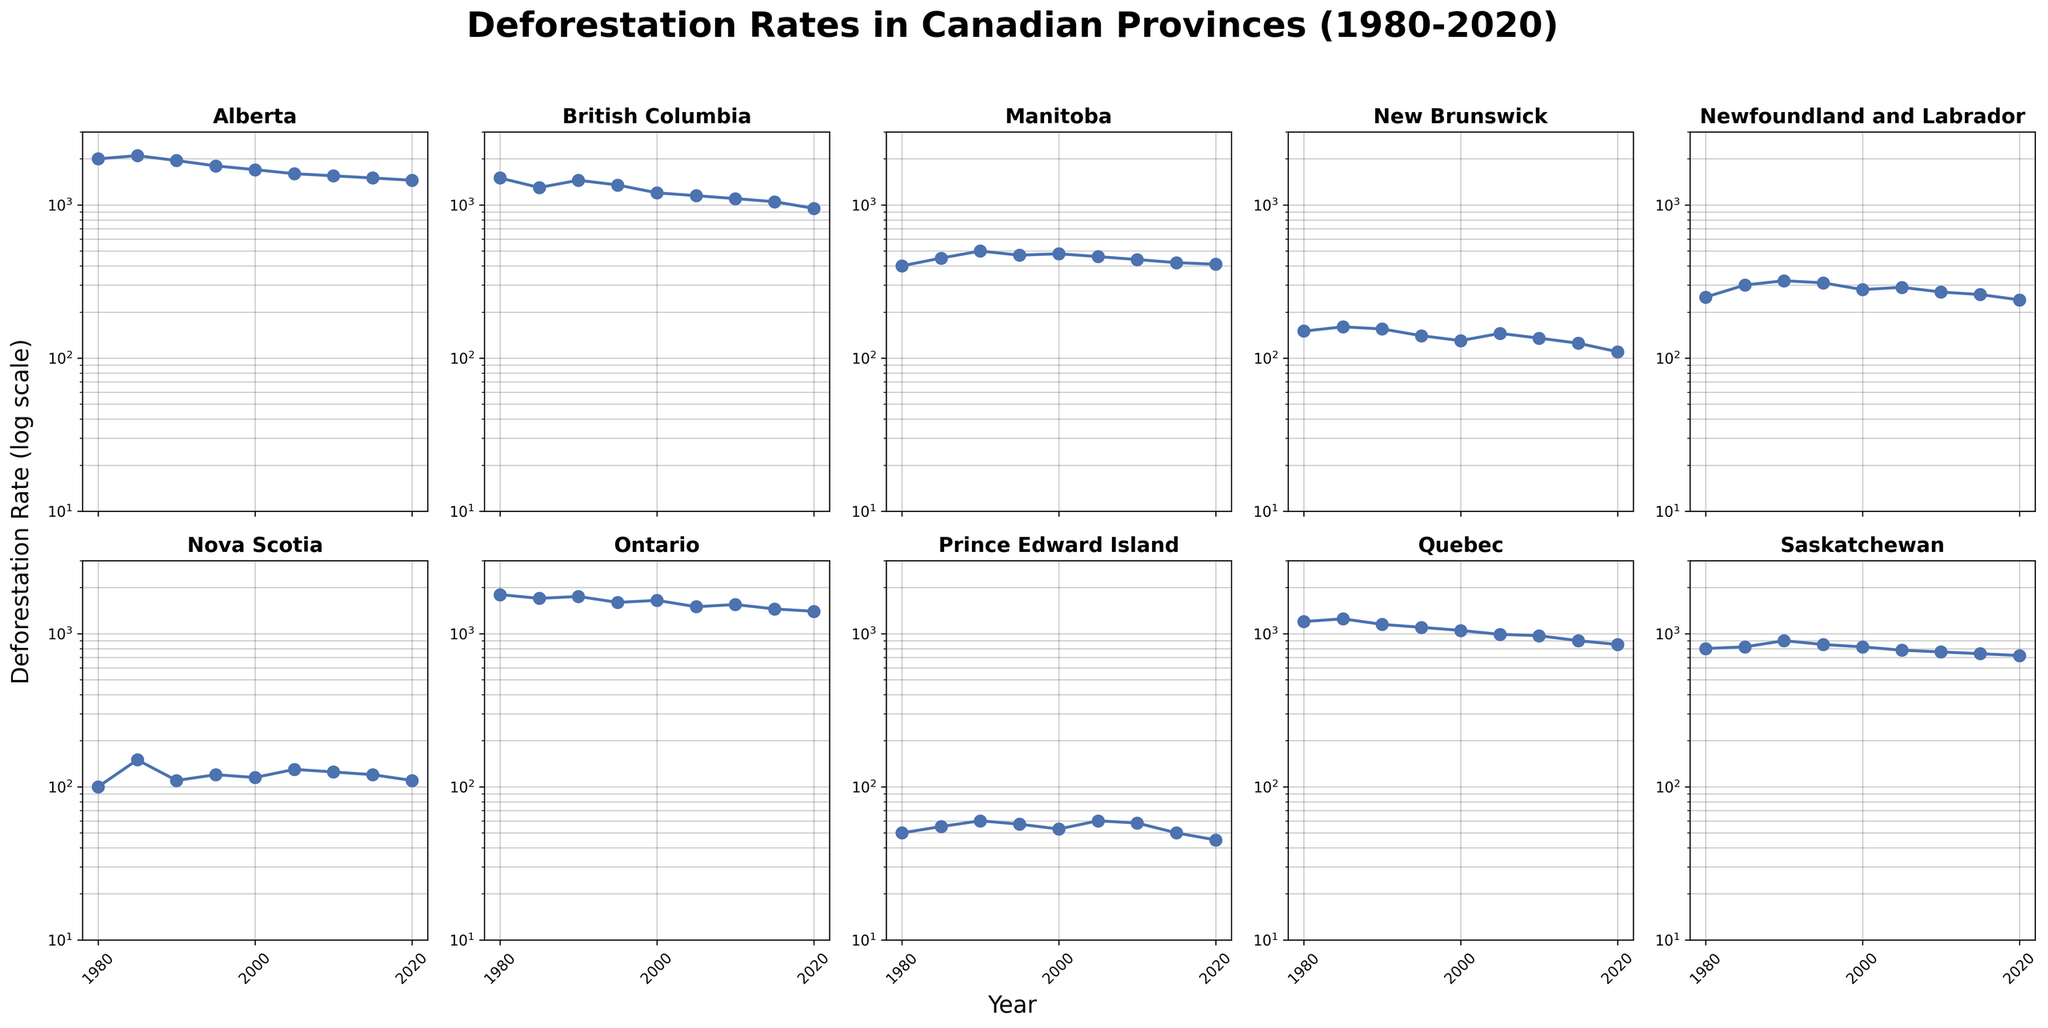Which province had the highest deforestation rate in 1980? The highest deforestation rate in 1980 can be identified by looking at the first data point in each subplot for the year 1980, which ranges from 50 to 2000. Alberta has the peak at 2000.
Answer: Alberta Which province shows the most significant decline in deforestation rates from 1980 to 2020? To determine the most significant decline, compare the deforestation rates in 1980 and 2020 for each province. Alberta drops from 2000 to 1450, British Columbia from 1500 to 950, Manitoba from 400 to 410, New Brunswick from 150 to 110, Newfoundland and Labrador from 250 to 240, Nova Scotia from 100 to 110, Ontario from 1800 to 1400, Prince Edward Island from 50 to 45, Quebec from 1200 to 850, and Saskatchewan from 800 to 720. Alberta has the largest decline from 2000 to 1450.
Answer: Alberta Which province had the lowest deforestation rate in 1980? To find the lowest deforestation rate in 1980, look at the rates for that year across all subplots. Prince Edward Island had the lowest at 50.
Answer: Prince Edward Island What is the general trend of deforestation rates in Nova Scotia from 1980 to 2020? Nova Scotia's deforestation rate starts at 100 in 1980, fluctuates slightly but remains relatively stable, and ends almost the same at 110 in 2020.
Answer: Relatively stable Which province had a higher deforestation rate in 2010, Ontario or Quebec? In 2010, Ontario's deforestation rate is approximately 1550, while Quebec's rate is around 970.
Answer: Ontario Which two provinces had the most similar deforestation rates in 2020? Compare deforestation rates for 2020 across all subplots. Saskatchewan and Quebec have rates of 720 and 850 respectively, making them the closest in value.
Answer: Saskatchewan and Quebec How does the deforestation rate in British Columbia change over time? British Columbia's deforestation rate starts at 1500 in 1980, fluctuates downward through the years, and ends at 950 in 2020, showing a general declining trend.
Answer: Declining What is the range of deforestation rates in Ontario over the years? Find the minimum and maximum deforestation rates in Ontario's subplot. The highest is 1800 (1980) and the lowest is 1400 (2020). The range is 1800 - 1400 = 400.
Answer: 400 Is there any province where the deforestation rate has increased from 1980 to 2020? For each subplot, compare the 1980 and 2020 data points. Except for Manitoba and Nova Scotia which remained stable, all other provinces’ rates declined, making the general trend consistent.
Answer: No 